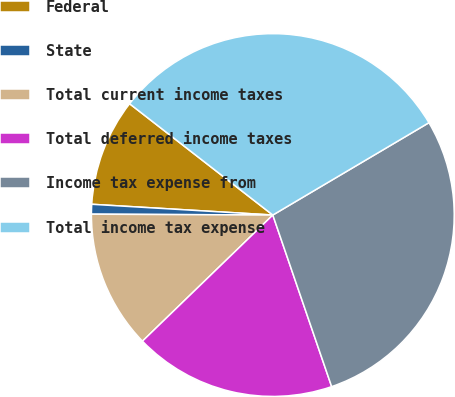<chart> <loc_0><loc_0><loc_500><loc_500><pie_chart><fcel>Federal<fcel>State<fcel>Total current income taxes<fcel>Total deferred income taxes<fcel>Income tax expense from<fcel>Total income tax expense<nl><fcel>9.57%<fcel>0.87%<fcel>12.31%<fcel>18.02%<fcel>28.24%<fcel>30.98%<nl></chart> 